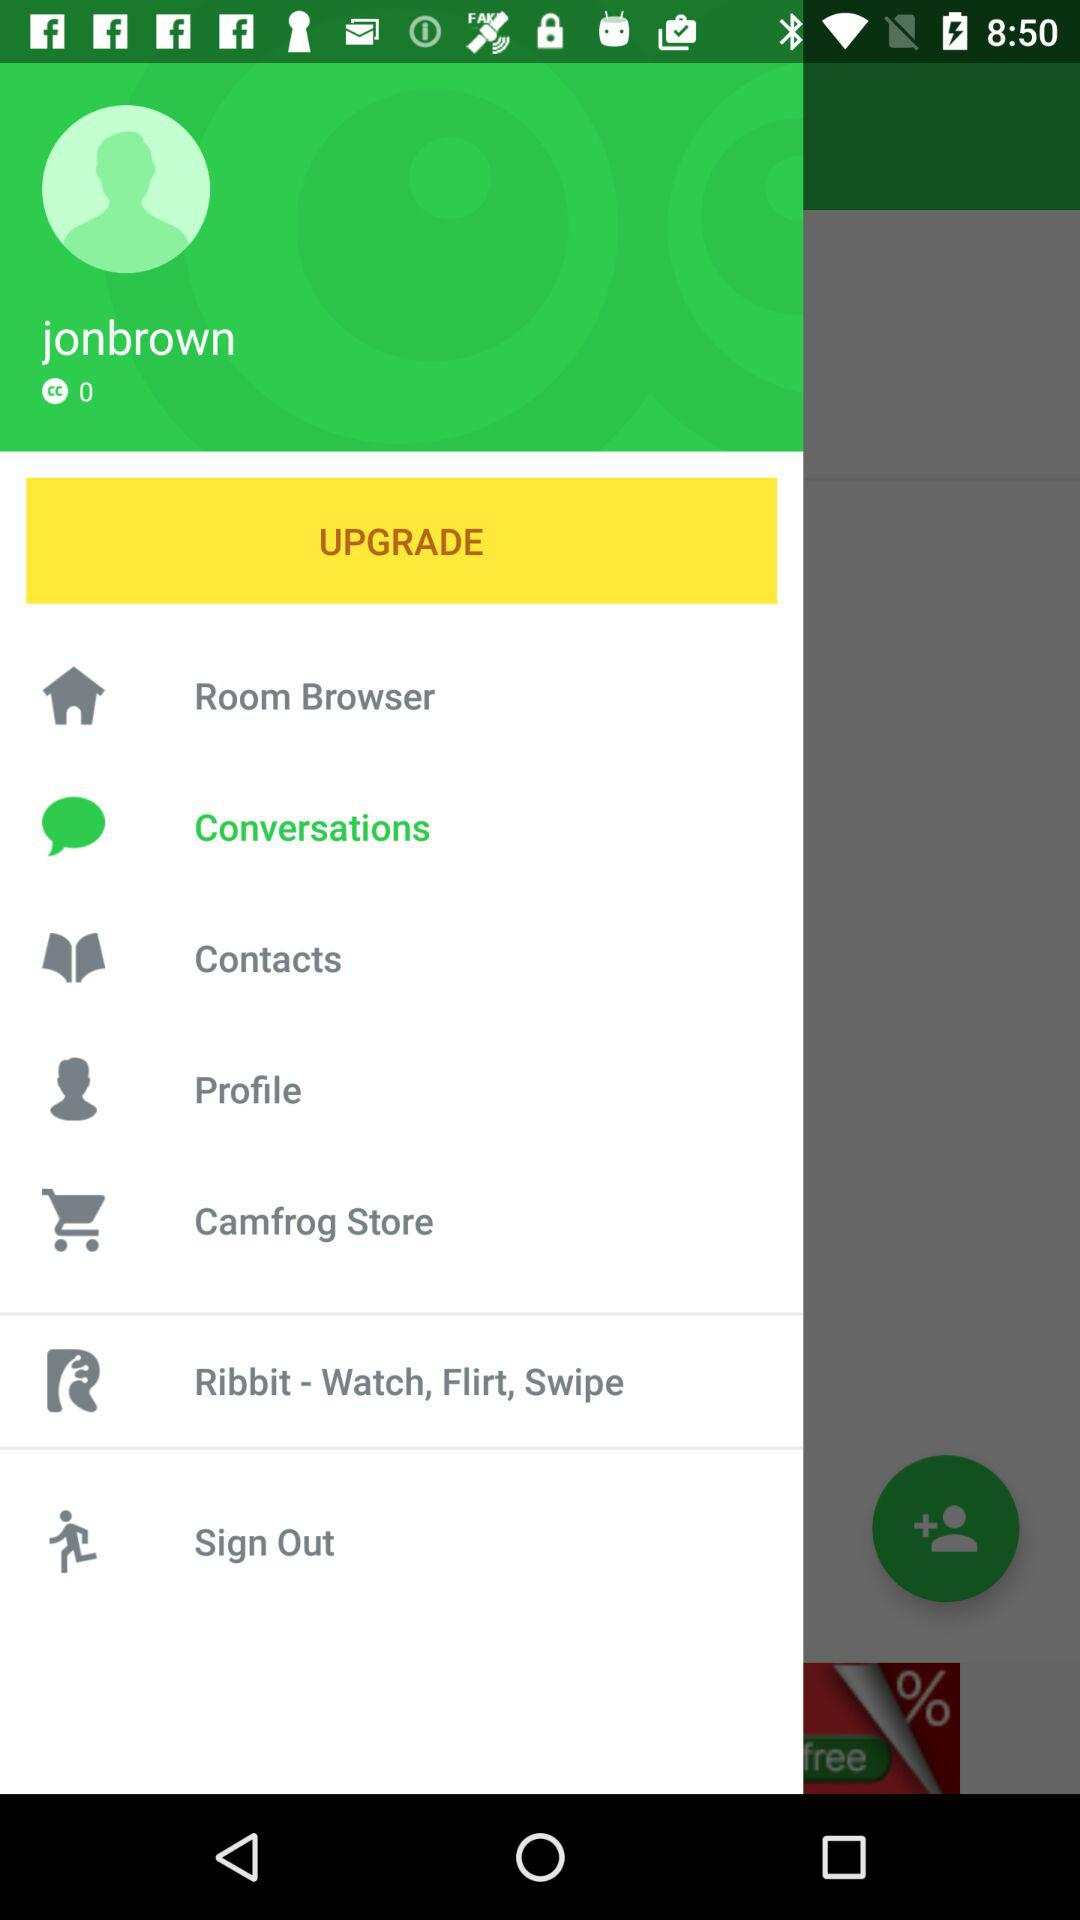What is the selected item? The selected item is "Conversations". 